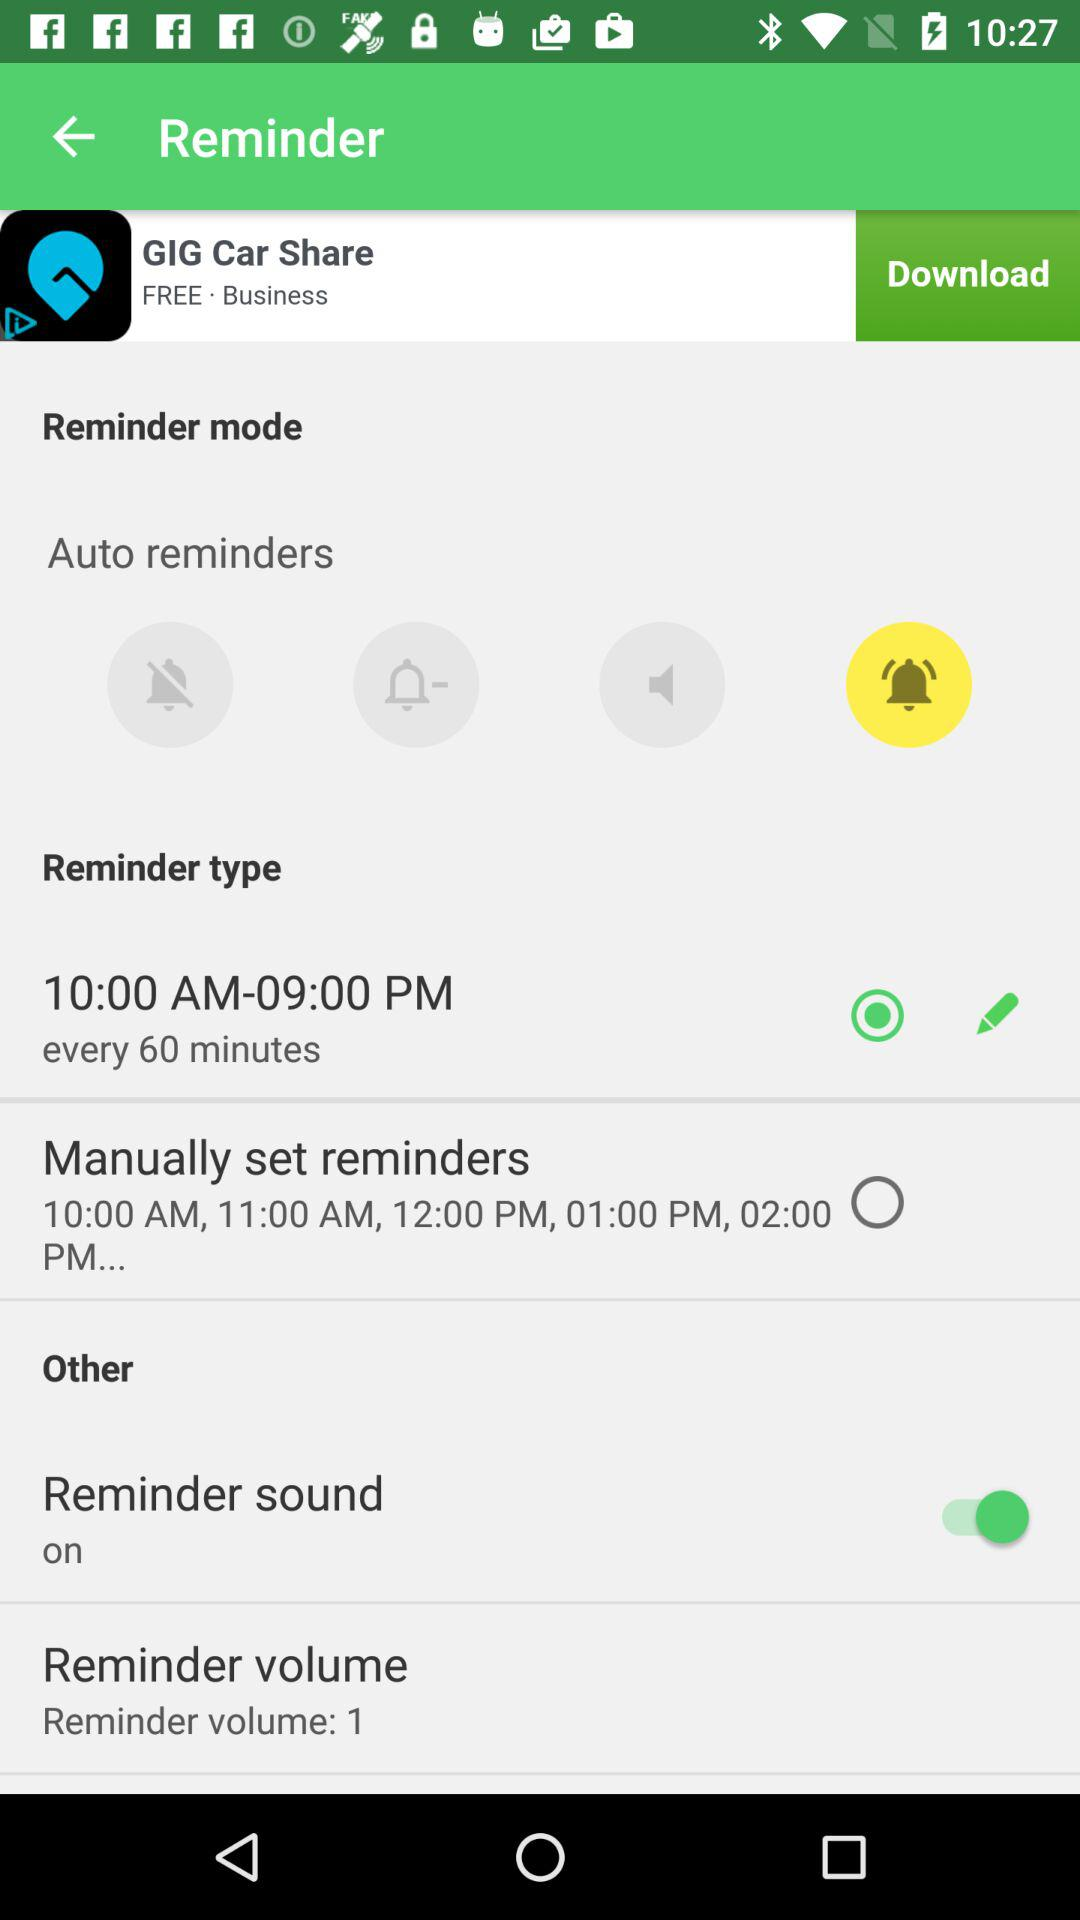Which reminder type is selected? The selected reminder type is "10:00 AM-09:00 PM". 